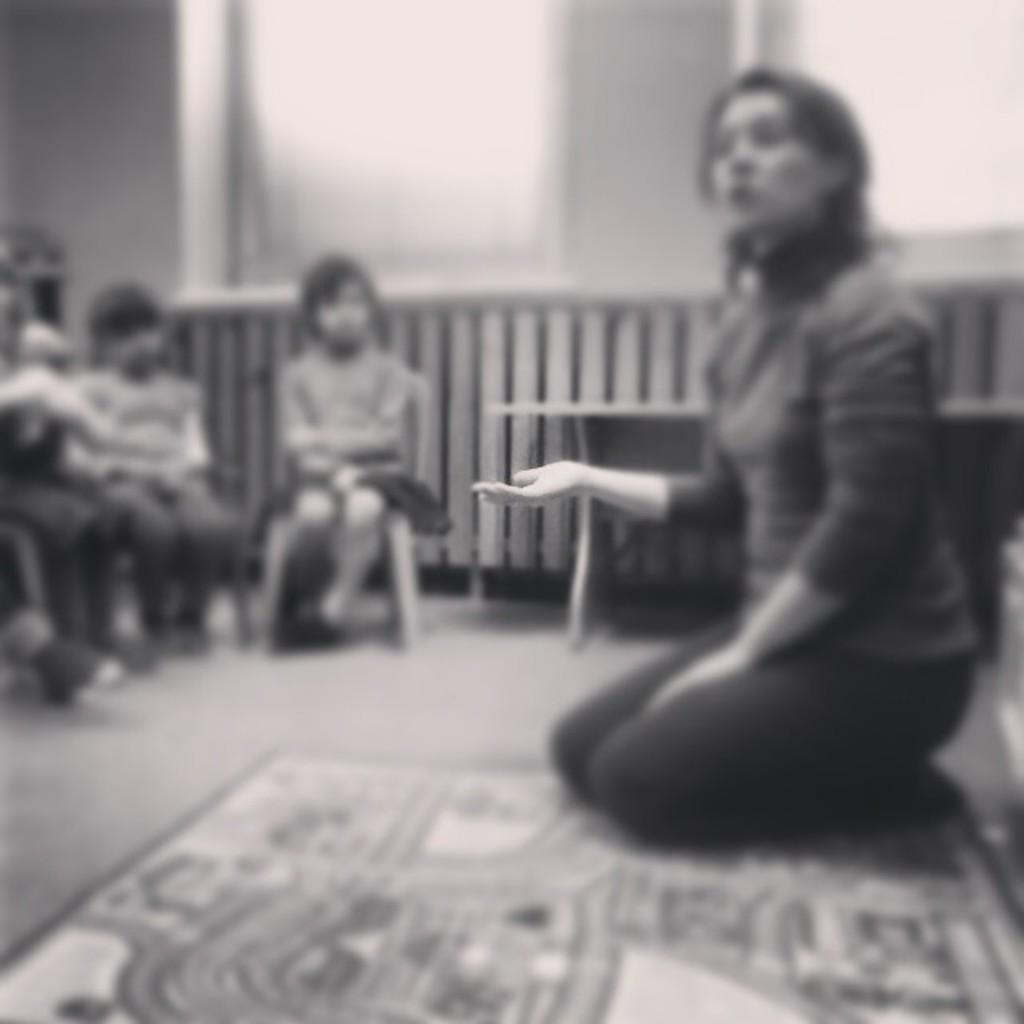What is the woman in the image doing? The woman is sitting on the floor in the image. How are the other persons in the image positioned? The other persons are sitting on chairs in the image. What is on the floor where the woman is sitting? There is a mat on the floor in the image. What can be seen in the background of the image? There is a wall and windows in the background of the image. What type of wrench is being used to fix the cave in the image? There is no cave or wrench present in the image. How many drops of water can be seen falling from the ceiling in the image? There is no water or ceiling visible in the image. 